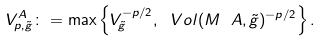Convert formula to latex. <formula><loc_0><loc_0><loc_500><loc_500>V _ { p , \tilde { g } } ^ { A } \colon = \max \left \{ V _ { \tilde { g } } ^ { - p / 2 } , \ V o l ( M \ A , \tilde { g } ) ^ { - p / 2 } \right \} .</formula> 